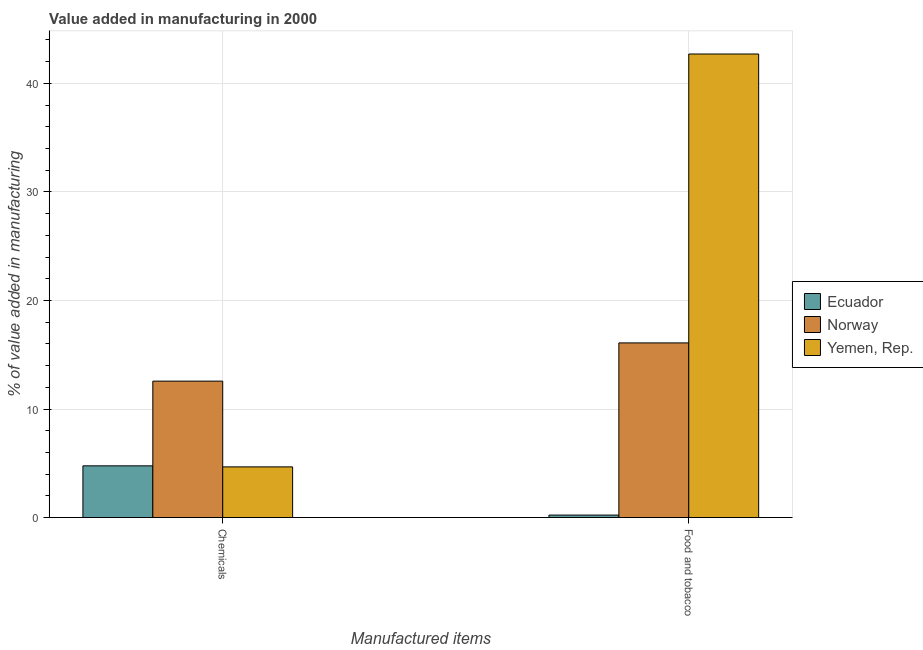How many different coloured bars are there?
Make the answer very short. 3. Are the number of bars per tick equal to the number of legend labels?
Make the answer very short. Yes. Are the number of bars on each tick of the X-axis equal?
Your answer should be compact. Yes. How many bars are there on the 1st tick from the left?
Your answer should be compact. 3. What is the label of the 2nd group of bars from the left?
Keep it short and to the point. Food and tobacco. What is the value added by manufacturing food and tobacco in Ecuador?
Keep it short and to the point. 0.23. Across all countries, what is the maximum value added by manufacturing food and tobacco?
Provide a short and direct response. 42.7. Across all countries, what is the minimum value added by manufacturing food and tobacco?
Offer a terse response. 0.23. In which country was the value added by  manufacturing chemicals maximum?
Your response must be concise. Norway. In which country was the value added by  manufacturing chemicals minimum?
Your response must be concise. Yemen, Rep. What is the total value added by manufacturing food and tobacco in the graph?
Keep it short and to the point. 59.02. What is the difference between the value added by  manufacturing chemicals in Norway and that in Ecuador?
Your answer should be compact. 7.8. What is the difference between the value added by manufacturing food and tobacco in Ecuador and the value added by  manufacturing chemicals in Yemen, Rep.?
Offer a terse response. -4.44. What is the average value added by  manufacturing chemicals per country?
Give a very brief answer. 7.33. What is the difference between the value added by  manufacturing chemicals and value added by manufacturing food and tobacco in Norway?
Provide a succinct answer. -3.52. What is the ratio of the value added by  manufacturing chemicals in Yemen, Rep. to that in Ecuador?
Your answer should be compact. 0.98. In how many countries, is the value added by  manufacturing chemicals greater than the average value added by  manufacturing chemicals taken over all countries?
Provide a short and direct response. 1. What does the 3rd bar from the right in Food and tobacco represents?
Offer a terse response. Ecuador. How many countries are there in the graph?
Make the answer very short. 3. What is the difference between two consecutive major ticks on the Y-axis?
Offer a terse response. 10. Does the graph contain grids?
Ensure brevity in your answer.  Yes. How are the legend labels stacked?
Ensure brevity in your answer.  Vertical. What is the title of the graph?
Your answer should be compact. Value added in manufacturing in 2000. What is the label or title of the X-axis?
Offer a terse response. Manufactured items. What is the label or title of the Y-axis?
Offer a terse response. % of value added in manufacturing. What is the % of value added in manufacturing of Ecuador in Chemicals?
Offer a very short reply. 4.76. What is the % of value added in manufacturing in Norway in Chemicals?
Provide a short and direct response. 12.57. What is the % of value added in manufacturing in Yemen, Rep. in Chemicals?
Provide a short and direct response. 4.67. What is the % of value added in manufacturing of Ecuador in Food and tobacco?
Make the answer very short. 0.23. What is the % of value added in manufacturing in Norway in Food and tobacco?
Provide a short and direct response. 16.09. What is the % of value added in manufacturing in Yemen, Rep. in Food and tobacco?
Provide a short and direct response. 42.7. Across all Manufactured items, what is the maximum % of value added in manufacturing of Ecuador?
Make the answer very short. 4.76. Across all Manufactured items, what is the maximum % of value added in manufacturing in Norway?
Make the answer very short. 16.09. Across all Manufactured items, what is the maximum % of value added in manufacturing in Yemen, Rep.?
Provide a succinct answer. 42.7. Across all Manufactured items, what is the minimum % of value added in manufacturing in Ecuador?
Offer a terse response. 0.23. Across all Manufactured items, what is the minimum % of value added in manufacturing of Norway?
Your response must be concise. 12.57. Across all Manufactured items, what is the minimum % of value added in manufacturing of Yemen, Rep.?
Offer a terse response. 4.67. What is the total % of value added in manufacturing of Ecuador in the graph?
Offer a terse response. 4.99. What is the total % of value added in manufacturing in Norway in the graph?
Your answer should be very brief. 28.66. What is the total % of value added in manufacturing of Yemen, Rep. in the graph?
Make the answer very short. 47.37. What is the difference between the % of value added in manufacturing of Ecuador in Chemicals and that in Food and tobacco?
Your response must be concise. 4.54. What is the difference between the % of value added in manufacturing of Norway in Chemicals and that in Food and tobacco?
Provide a short and direct response. -3.52. What is the difference between the % of value added in manufacturing of Yemen, Rep. in Chemicals and that in Food and tobacco?
Your response must be concise. -38.03. What is the difference between the % of value added in manufacturing in Ecuador in Chemicals and the % of value added in manufacturing in Norway in Food and tobacco?
Ensure brevity in your answer.  -11.33. What is the difference between the % of value added in manufacturing in Ecuador in Chemicals and the % of value added in manufacturing in Yemen, Rep. in Food and tobacco?
Offer a very short reply. -37.94. What is the difference between the % of value added in manufacturing of Norway in Chemicals and the % of value added in manufacturing of Yemen, Rep. in Food and tobacco?
Your response must be concise. -30.14. What is the average % of value added in manufacturing of Ecuador per Manufactured items?
Offer a terse response. 2.5. What is the average % of value added in manufacturing of Norway per Manufactured items?
Offer a very short reply. 14.33. What is the average % of value added in manufacturing of Yemen, Rep. per Manufactured items?
Offer a very short reply. 23.69. What is the difference between the % of value added in manufacturing of Ecuador and % of value added in manufacturing of Norway in Chemicals?
Provide a short and direct response. -7.8. What is the difference between the % of value added in manufacturing in Ecuador and % of value added in manufacturing in Yemen, Rep. in Chemicals?
Ensure brevity in your answer.  0.1. What is the difference between the % of value added in manufacturing in Norway and % of value added in manufacturing in Yemen, Rep. in Chemicals?
Give a very brief answer. 7.9. What is the difference between the % of value added in manufacturing in Ecuador and % of value added in manufacturing in Norway in Food and tobacco?
Offer a terse response. -15.86. What is the difference between the % of value added in manufacturing of Ecuador and % of value added in manufacturing of Yemen, Rep. in Food and tobacco?
Your answer should be very brief. -42.47. What is the difference between the % of value added in manufacturing of Norway and % of value added in manufacturing of Yemen, Rep. in Food and tobacco?
Provide a succinct answer. -26.61. What is the ratio of the % of value added in manufacturing in Ecuador in Chemicals to that in Food and tobacco?
Make the answer very short. 20.89. What is the ratio of the % of value added in manufacturing in Norway in Chemicals to that in Food and tobacco?
Your answer should be compact. 0.78. What is the ratio of the % of value added in manufacturing of Yemen, Rep. in Chemicals to that in Food and tobacco?
Ensure brevity in your answer.  0.11. What is the difference between the highest and the second highest % of value added in manufacturing in Ecuador?
Your answer should be very brief. 4.54. What is the difference between the highest and the second highest % of value added in manufacturing of Norway?
Your answer should be very brief. 3.52. What is the difference between the highest and the second highest % of value added in manufacturing in Yemen, Rep.?
Ensure brevity in your answer.  38.03. What is the difference between the highest and the lowest % of value added in manufacturing in Ecuador?
Give a very brief answer. 4.54. What is the difference between the highest and the lowest % of value added in manufacturing in Norway?
Provide a short and direct response. 3.52. What is the difference between the highest and the lowest % of value added in manufacturing of Yemen, Rep.?
Offer a very short reply. 38.03. 